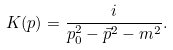<formula> <loc_0><loc_0><loc_500><loc_500>K ( p ) = { \frac { i } { p _ { 0 } ^ { 2 } - { \vec { p } } ^ { 2 } - m ^ { 2 } } } .</formula> 